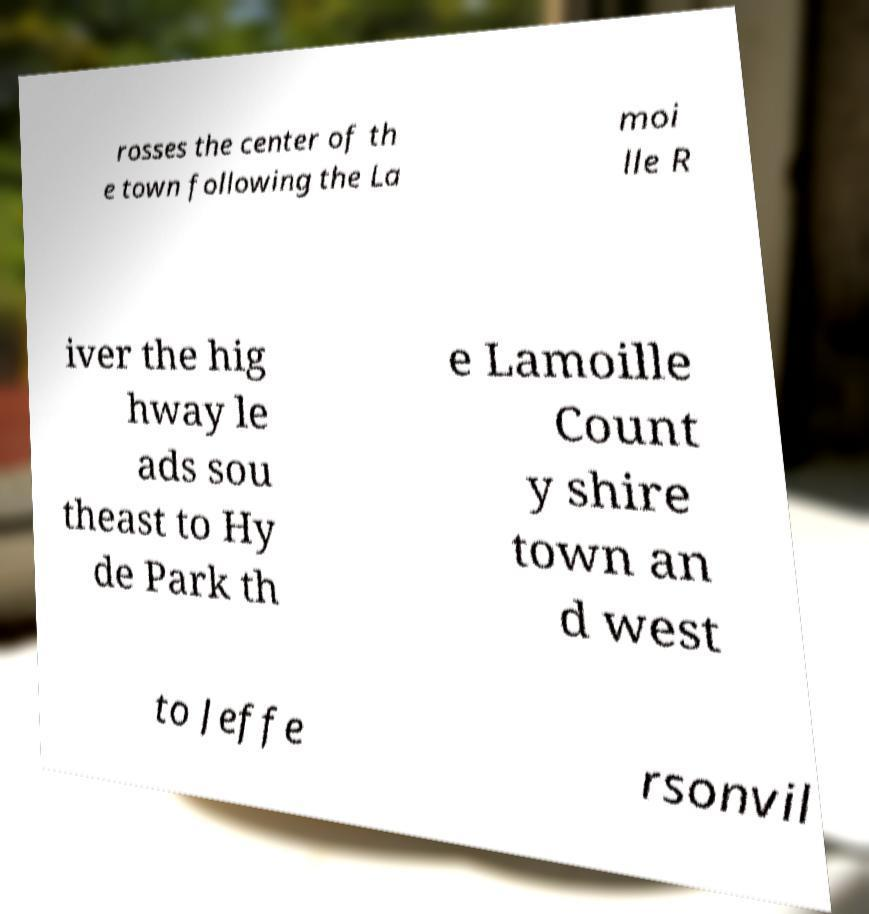Could you assist in decoding the text presented in this image and type it out clearly? rosses the center of th e town following the La moi lle R iver the hig hway le ads sou theast to Hy de Park th e Lamoille Count y shire town an d west to Jeffe rsonvil 